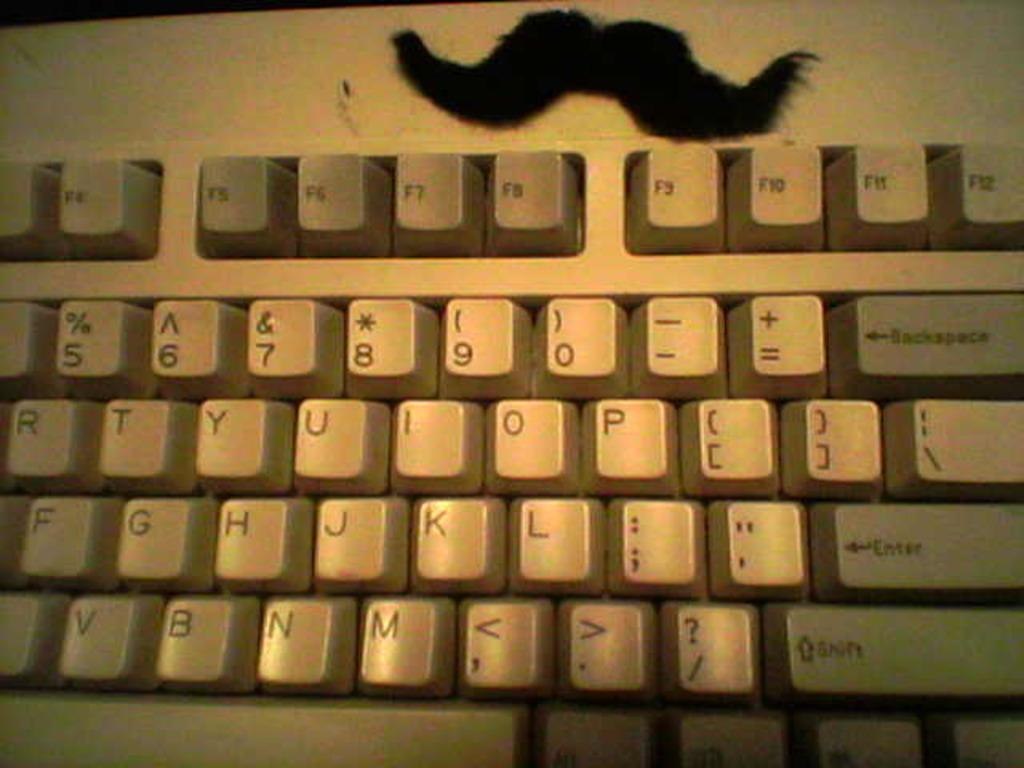<image>
Share a concise interpretation of the image provided. A mustache is placed above the F keys on a keyboard. 